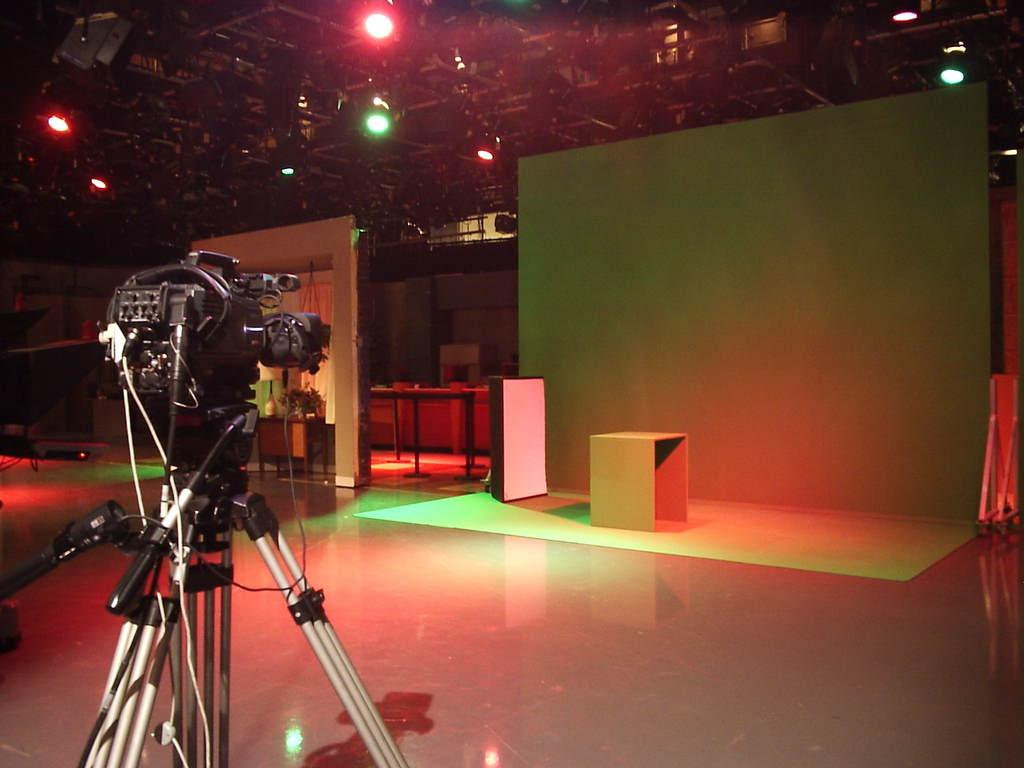What is the main object in the image? There is a tripod in the image. What is attached to the tripod? There is a camera attached to the tripod. What is located at the top of the image? There are lights at the top of the image. What color is the background of the image? The background of the image is green. What is the purpose of the table in the image? The table might be used to hold equipment or provide a surface for the camera. What type of sound can be heard coming from the building in the image? There is no building present in the image, so it's not possible to determine what, if any, sounds might be heard. 